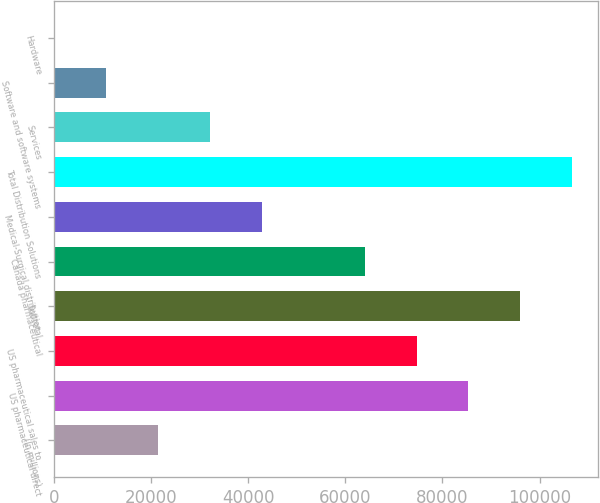Convert chart. <chart><loc_0><loc_0><loc_500><loc_500><bar_chart><fcel>(In millions)<fcel>US pharmaceutical direct<fcel>US pharmaceutical sales to<fcel>Subtotal<fcel>Canada pharmaceutical<fcel>Medical-Surgical distribution<fcel>Total Distribution Solutions<fcel>Services<fcel>Software and software systems<fcel>Hardware<nl><fcel>21450.4<fcel>85336.6<fcel>74688.9<fcel>95984.3<fcel>64041.2<fcel>42745.8<fcel>106632<fcel>32098.1<fcel>10802.7<fcel>155<nl></chart> 